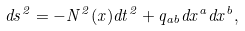<formula> <loc_0><loc_0><loc_500><loc_500>d s ^ { 2 } = - N ^ { 2 } ( x ) d t ^ { 2 } + q _ { a b } d x ^ { a } d x ^ { b } ,</formula> 